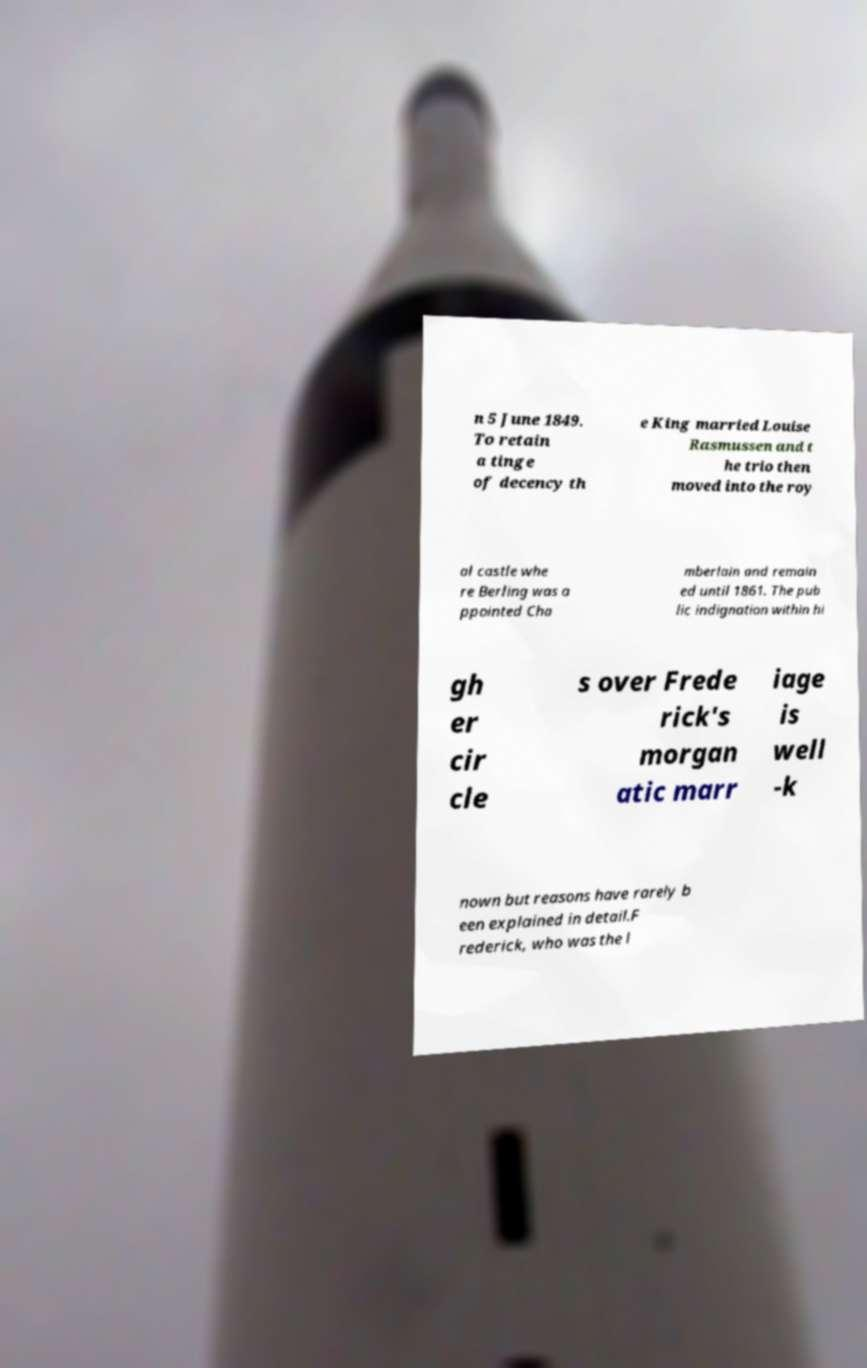Please read and relay the text visible in this image. What does it say? n 5 June 1849. To retain a tinge of decency th e King married Louise Rasmussen and t he trio then moved into the roy al castle whe re Berling was a ppointed Cha mberlain and remain ed until 1861. The pub lic indignation within hi gh er cir cle s over Frede rick's morgan atic marr iage is well -k nown but reasons have rarely b een explained in detail.F rederick, who was the l 